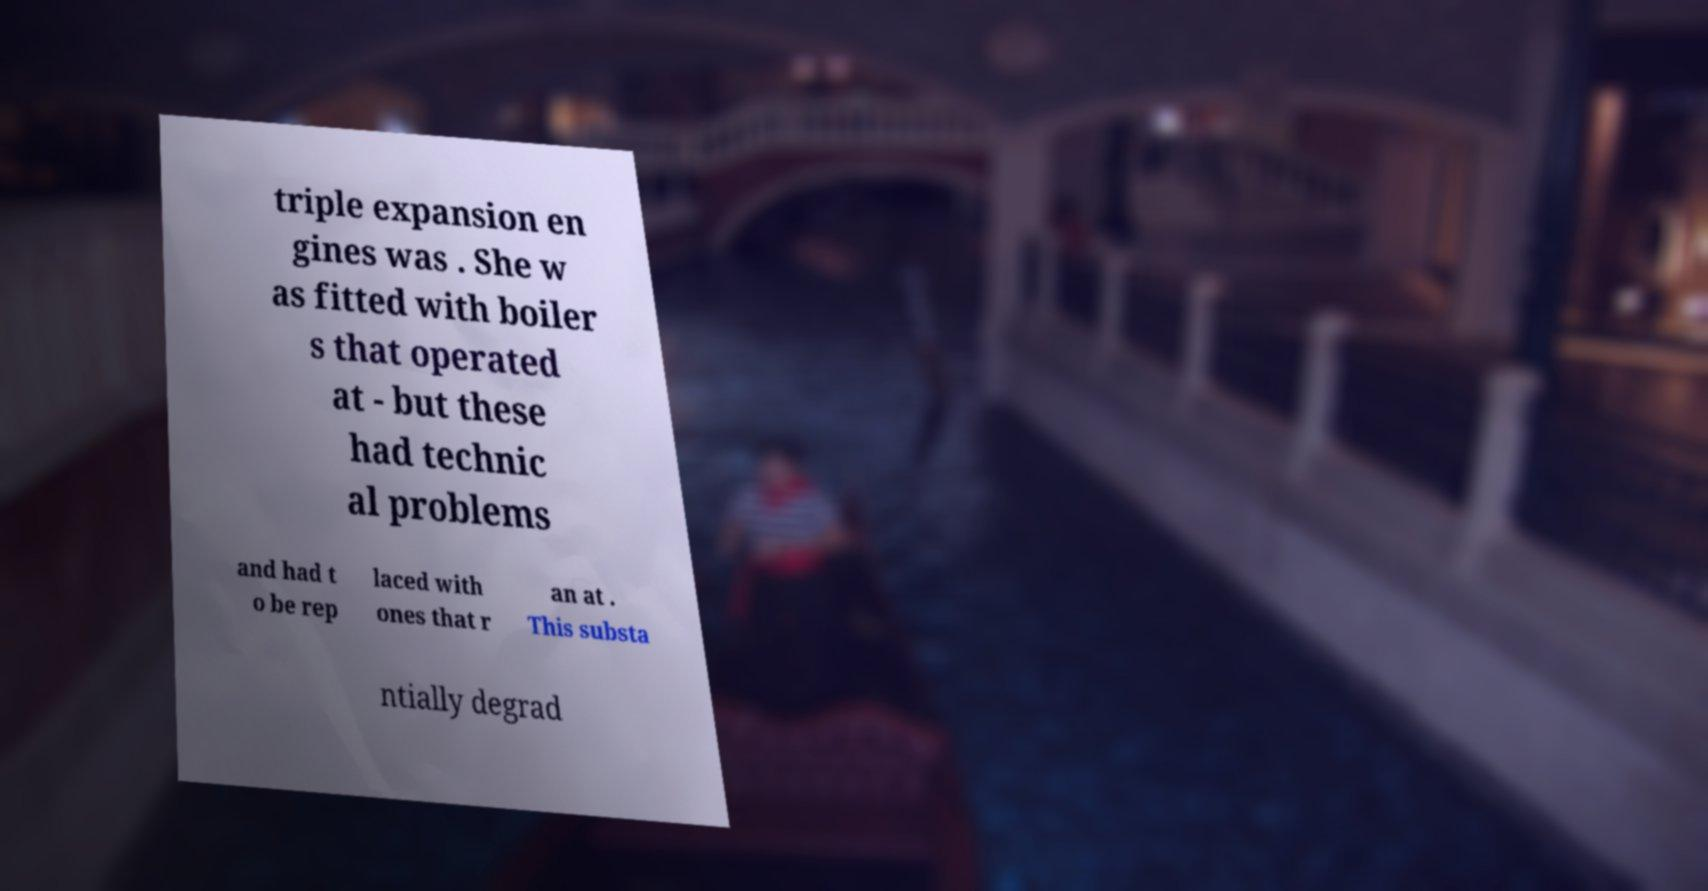Could you assist in decoding the text presented in this image and type it out clearly? triple expansion en gines was . She w as fitted with boiler s that operated at - but these had technic al problems and had t o be rep laced with ones that r an at . This substa ntially degrad 